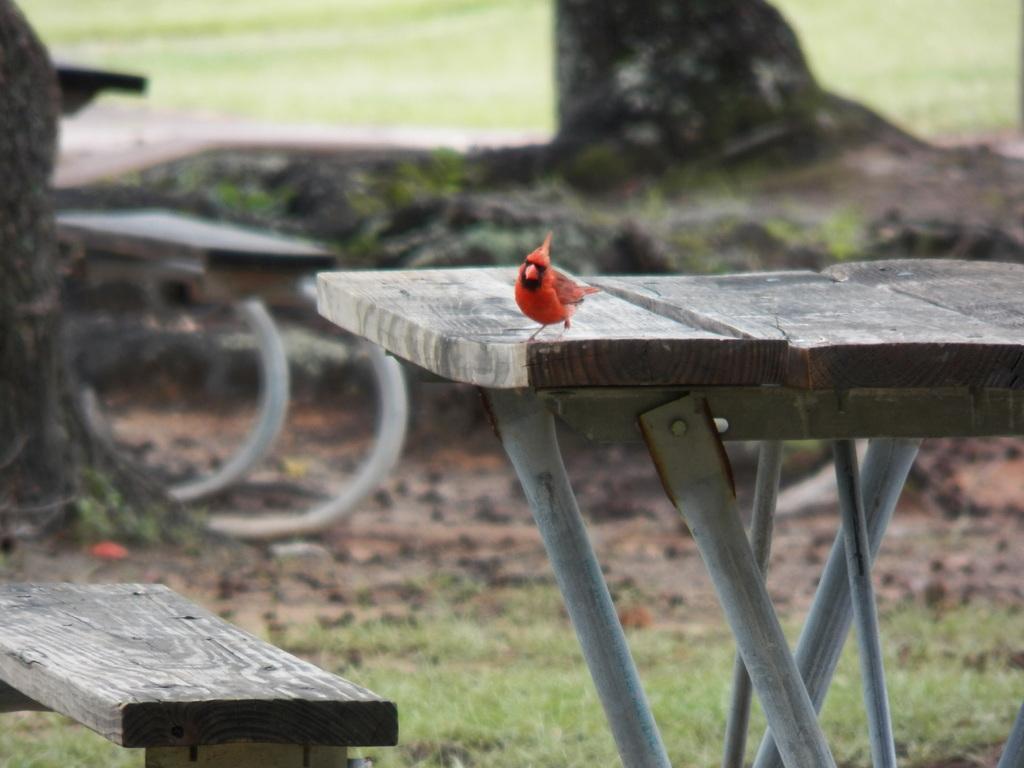Could you give a brief overview of what you see in this image? In this picture we can see a bird on this wooden table. 